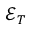<formula> <loc_0><loc_0><loc_500><loc_500>{ \mathcal { E } } _ { T }</formula> 